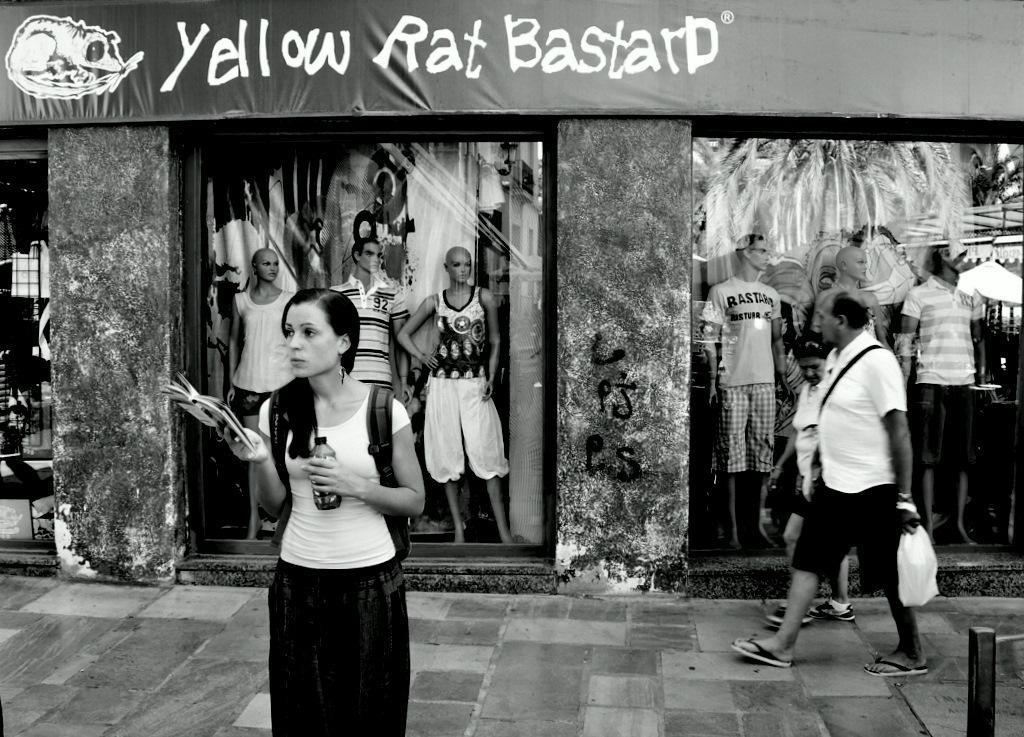What is the color scheme of the image? The image is black and white. Who or what can be seen in the image? There are people and mannequins in the image. What else is present in the image besides people and mannequins? Clothes and pillars are present in the image. Can you describe any other objects in the image? There is a board in the image. How many horses are present in the image? There are no horses present in the image. What type of business is being conducted in the image? The image does not depict any business activities; it features people, mannequins, clothes, pillars, and a board. 